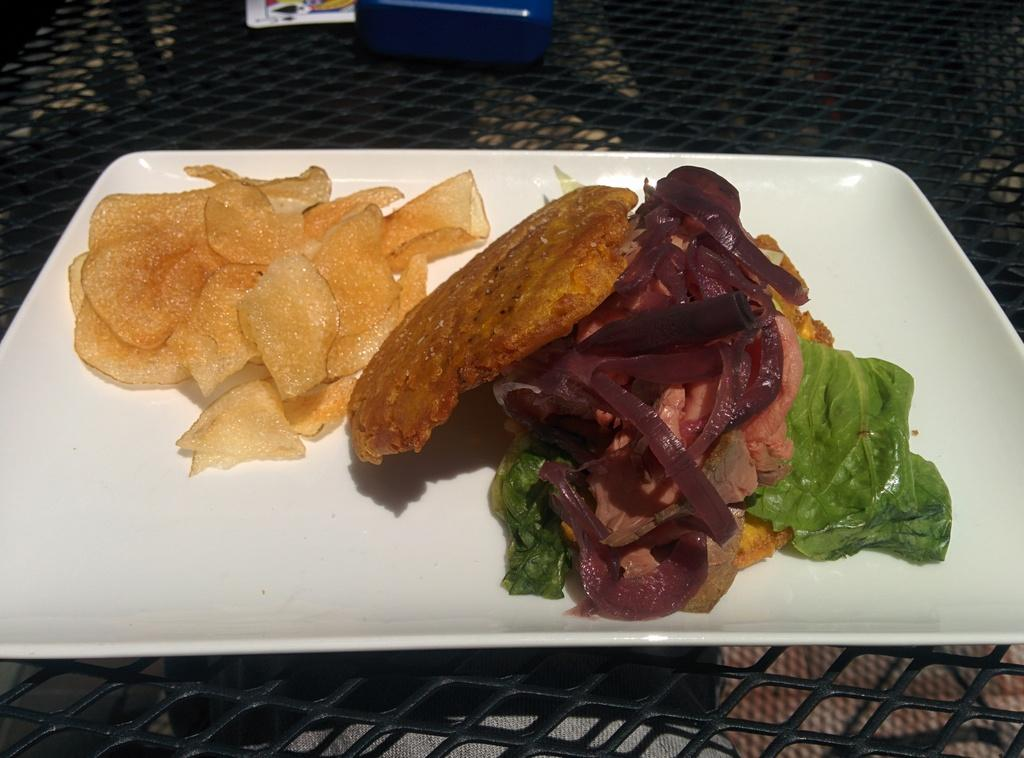What is on the plate that is visible in the image? The plate contains food such as meat, green leaves, and chips. Where is the plate located in the image? The plate is placed on a table. What else can be seen in the image besides the plate? There are objects visible at the top of the image. What verse can be found in the notebook at the top of the image? There is no notebook or verse present in the image. 